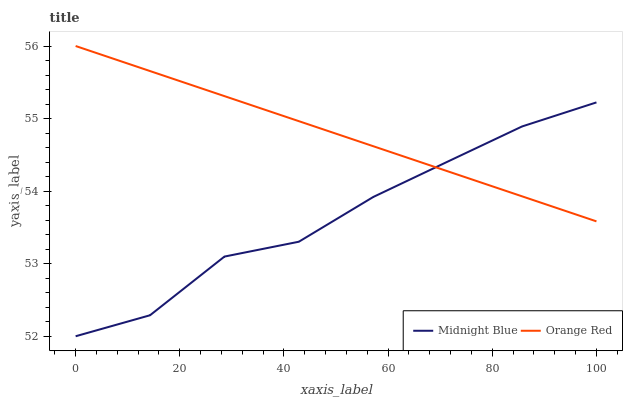Does Midnight Blue have the minimum area under the curve?
Answer yes or no. Yes. Does Orange Red have the maximum area under the curve?
Answer yes or no. Yes. Does Orange Red have the minimum area under the curve?
Answer yes or no. No. Is Orange Red the smoothest?
Answer yes or no. Yes. Is Midnight Blue the roughest?
Answer yes or no. Yes. Is Orange Red the roughest?
Answer yes or no. No. Does Midnight Blue have the lowest value?
Answer yes or no. Yes. Does Orange Red have the lowest value?
Answer yes or no. No. Does Orange Red have the highest value?
Answer yes or no. Yes. Does Orange Red intersect Midnight Blue?
Answer yes or no. Yes. Is Orange Red less than Midnight Blue?
Answer yes or no. No. Is Orange Red greater than Midnight Blue?
Answer yes or no. No. 